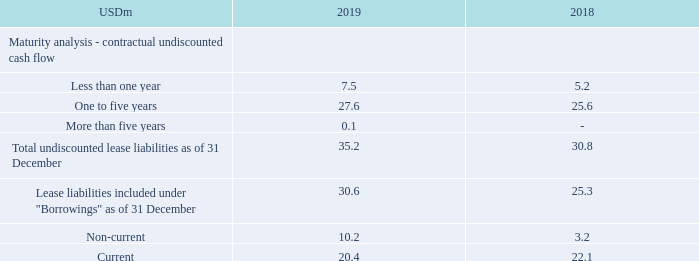Lease liabilities regarding right-of-use assets are included on the balance sheet under “Borrowings”.
Extension and termination options are included in several leases in order to optimize operational flexibility in terms of managing contracts. The lease term determined by TORM is the noncancellable period of a lease, together with any extension/termination options if these are/are not reasonably certain to be exercised.
Why are extension and termination options are included in several leases? To optimize operational flexibility in terms of managing contracts. What is the lease term determined by TORM? The noncancellable period of a lease, together with any extension/termination options if these are/are not reasonably certain to be exercised. What are the different maturity terms under maturity analysis - contractual undiscounted cash flow? Less than one year, one to five years, more than five years. In which year was the amount of Current lease liabilities larger? 22.1>20.4
Answer: 2018. What was the change in non-current lease liabilities?
Answer scale should be: million. 10.2-3.2
Answer: 7. What was the percentage change in non-current lease liabilities?
Answer scale should be: percent. (10.2-3.2)/3.2
Answer: 218.75. 